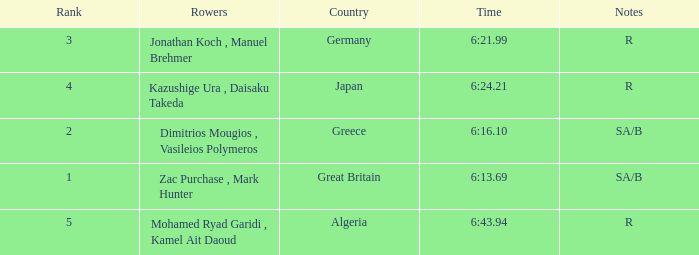What's the time of Rank 3? 6:21.99. 